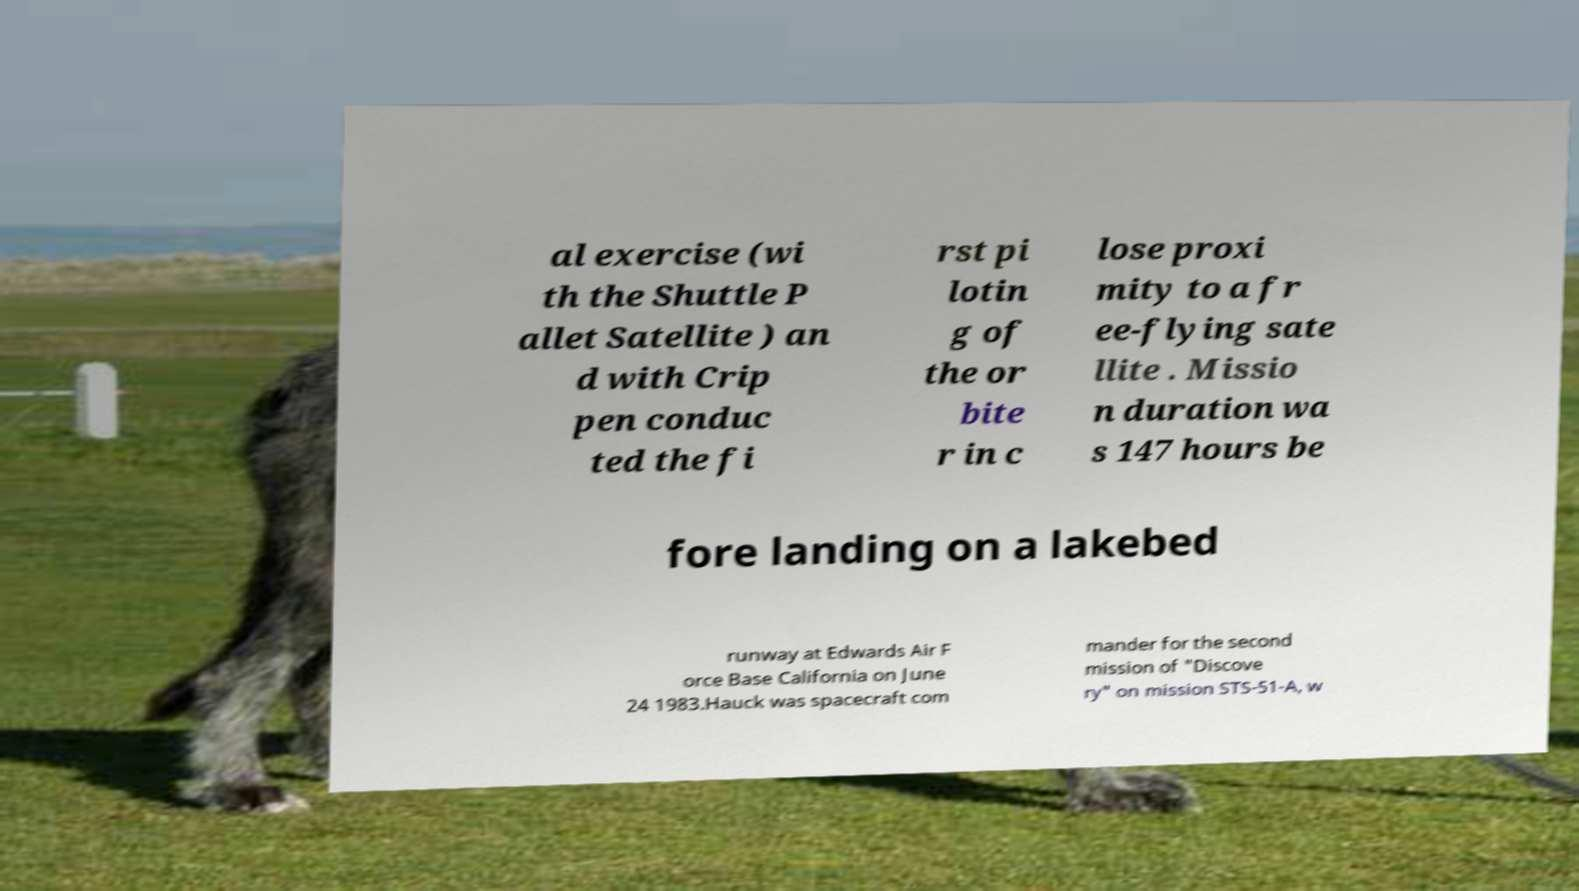Can you accurately transcribe the text from the provided image for me? al exercise (wi th the Shuttle P allet Satellite ) an d with Crip pen conduc ted the fi rst pi lotin g of the or bite r in c lose proxi mity to a fr ee-flying sate llite . Missio n duration wa s 147 hours be fore landing on a lakebed runway at Edwards Air F orce Base California on June 24 1983.Hauck was spacecraft com mander for the second mission of "Discove ry" on mission STS-51-A, w 